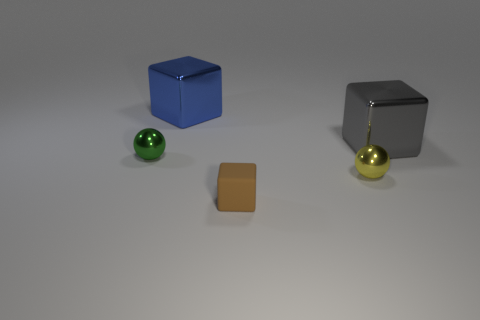Subtract all shiny cubes. How many cubes are left? 1 Subtract 1 balls. How many balls are left? 1 Subtract all balls. How many objects are left? 3 Add 4 yellow metallic cylinders. How many objects exist? 9 Subtract 0 green cylinders. How many objects are left? 5 Subtract all red blocks. Subtract all cyan spheres. How many blocks are left? 3 Subtract all tiny brown things. Subtract all tiny spheres. How many objects are left? 2 Add 5 yellow metallic spheres. How many yellow metallic spheres are left? 6 Add 1 tiny brown rubber blocks. How many tiny brown rubber blocks exist? 2 